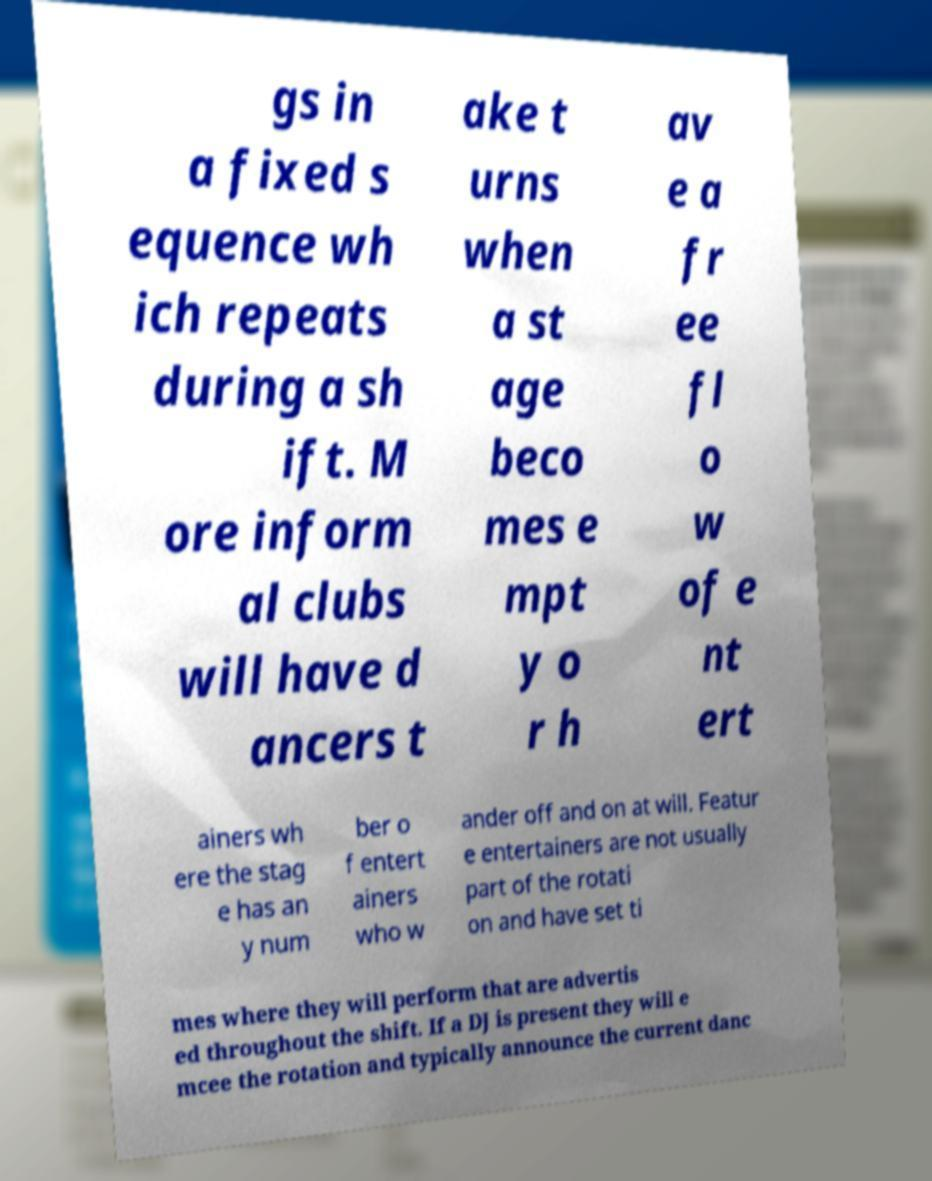What messages or text are displayed in this image? I need them in a readable, typed format. gs in a fixed s equence wh ich repeats during a sh ift. M ore inform al clubs will have d ancers t ake t urns when a st age beco mes e mpt y o r h av e a fr ee fl o w of e nt ert ainers wh ere the stag e has an y num ber o f entert ainers who w ander off and on at will. Featur e entertainers are not usually part of the rotati on and have set ti mes where they will perform that are advertis ed throughout the shift. If a DJ is present they will e mcee the rotation and typically announce the current danc 